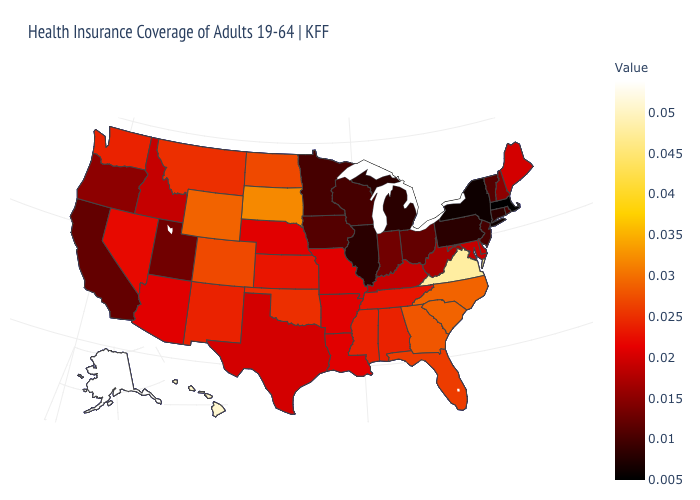Which states hav the highest value in the Northeast?
Concise answer only. Maine. Which states hav the highest value in the MidWest?
Write a very short answer. South Dakota. Among the states that border Rhode Island , does Connecticut have the highest value?
Keep it brief. Yes. Which states have the lowest value in the USA?
Short answer required. Massachusetts. Which states have the lowest value in the MidWest?
Write a very short answer. Illinois, Michigan. Does Alaska have a lower value than South Dakota?
Keep it brief. No. 